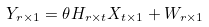<formula> <loc_0><loc_0><loc_500><loc_500>Y _ { r \times 1 } = \theta H _ { r \times t } X _ { t \times 1 } + W _ { r \times 1 }</formula> 